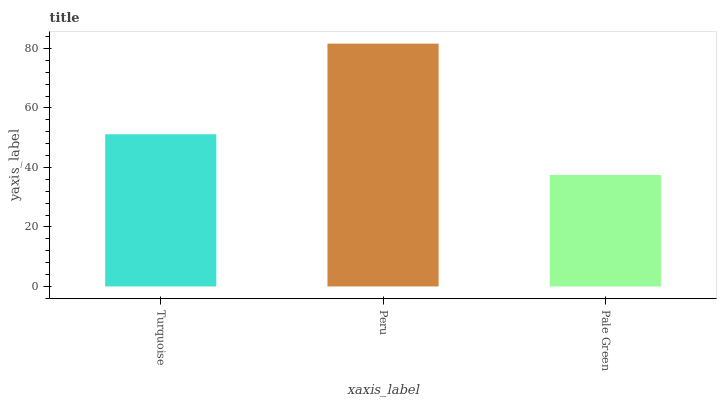Is Pale Green the minimum?
Answer yes or no. Yes. Is Peru the maximum?
Answer yes or no. Yes. Is Peru the minimum?
Answer yes or no. No. Is Pale Green the maximum?
Answer yes or no. No. Is Peru greater than Pale Green?
Answer yes or no. Yes. Is Pale Green less than Peru?
Answer yes or no. Yes. Is Pale Green greater than Peru?
Answer yes or no. No. Is Peru less than Pale Green?
Answer yes or no. No. Is Turquoise the high median?
Answer yes or no. Yes. Is Turquoise the low median?
Answer yes or no. Yes. Is Peru the high median?
Answer yes or no. No. Is Pale Green the low median?
Answer yes or no. No. 